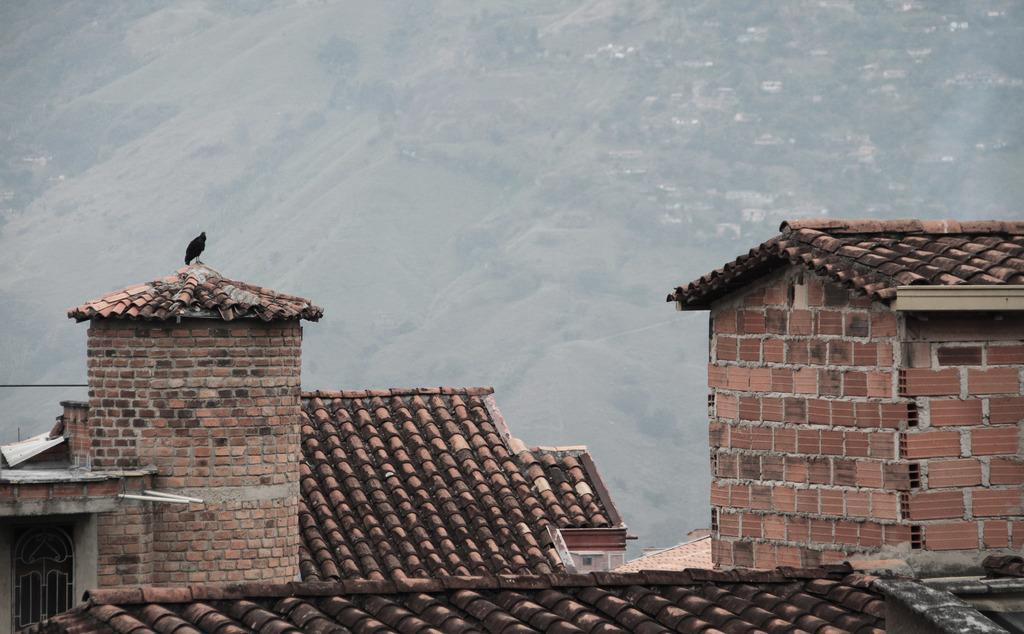Please provide a concise description of this image. As we can see in the image there are buildings and red color rooftops. In the background there are hills. Here there is a bird. 